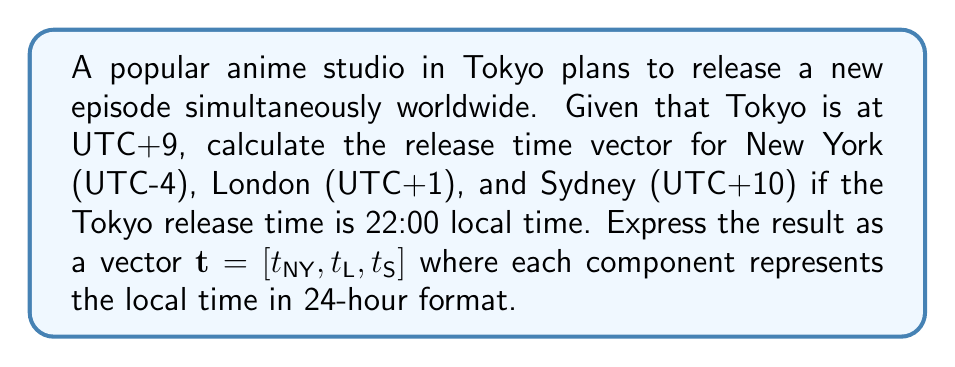Teach me how to tackle this problem. Let's approach this step-by-step using vector analysis:

1) First, we need to convert Tokyo's local time to UTC:
   Tokyo time = 22:00 (UTC+9)
   UTC time = 22:00 - 9:00 = 13:00 UTC

2) Now, we can represent the time zone offsets as a vector:
   $\mathbf{o} = [-4, 1, 10]$

3) The UTC time can be represented as a scalar: $u = 13$

4) To find the local times, we add the UTC time to each offset:
   $\mathbf{t} = u\mathbf{1} + \mathbf{o}$
   where $\mathbf{1}$ is a vector of ones: $[1, 1, 1]$

5) Calculating:
   $\mathbf{t} = 13[1, 1, 1] + [-4, 1, 10]$
   $\mathbf{t} = [13, 13, 13] + [-4, 1, 10]$
   $\mathbf{t} = [9, 14, 23]$

6) Interpreting the results:
   New York: 9:00 (or 09:00 in 24-hour format)
   London: 14:00
   Sydney: 23:00

Therefore, the release time vector is $\mathbf{t} = [09:00, 14:00, 23:00]$.
Answer: $\mathbf{t} = [09:00, 14:00, 23:00]$ 